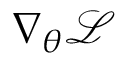Convert formula to latex. <formula><loc_0><loc_0><loc_500><loc_500>\nabla _ { \theta } \mathcal { L }</formula> 